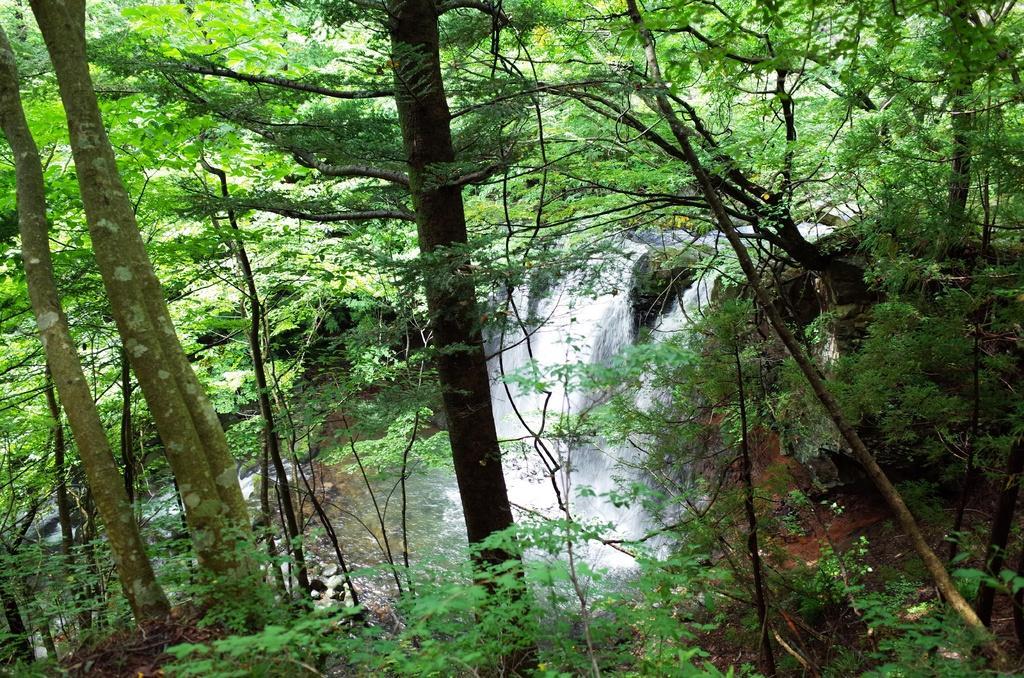In one or two sentences, can you explain what this image depicts? In this picture we can see few trees, water and rocks. 